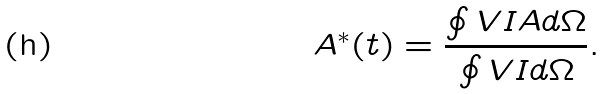<formula> <loc_0><loc_0><loc_500><loc_500>A ^ { * } ( t ) = \frac { \oint V I A d \Omega } { \oint V I d \Omega } .</formula> 